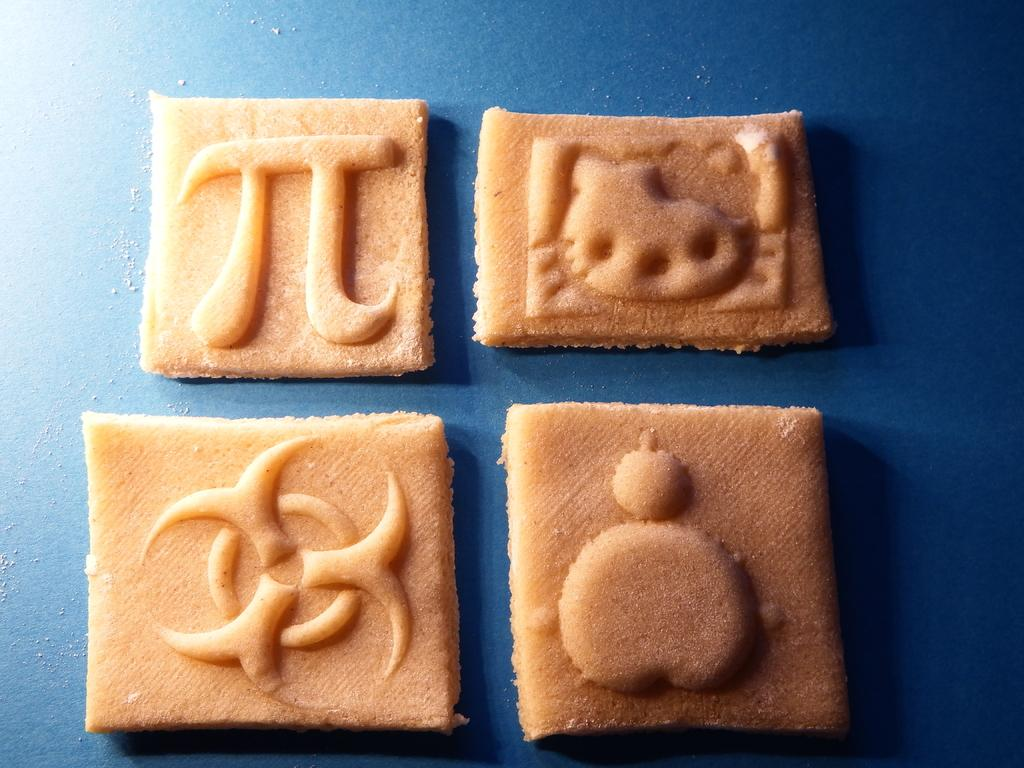How many biscuits are visible in the image? There are four biscuits in the image. What color is the background of the image? The background of the image is blue. What type of card can be seen in the pocket of the person in the image? There is no person or card present in the image; it only features four biscuits against a blue background. 